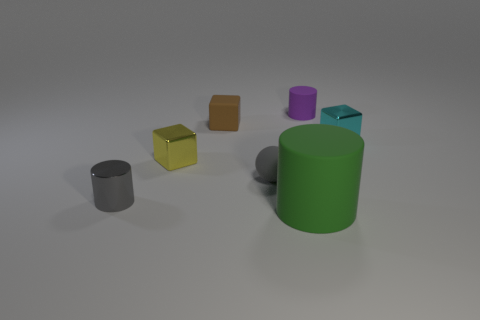Are there more small matte objects that are to the left of the big cylinder than tiny green balls?
Keep it short and to the point. Yes. Is there a block of the same color as the small sphere?
Provide a succinct answer. No. What color is the metal cylinder that is the same size as the sphere?
Your answer should be compact. Gray. There is a small cylinder that is to the right of the gray cylinder; are there any green rubber cylinders that are behind it?
Offer a terse response. No. What material is the tiny cylinder left of the tiny gray matte thing?
Your answer should be compact. Metal. Is the material of the small object that is right of the purple rubber thing the same as the small cylinder on the left side of the tiny purple cylinder?
Your answer should be compact. Yes. Are there an equal number of cubes that are on the left side of the tiny yellow thing and matte cylinders that are right of the large matte cylinder?
Keep it short and to the point. No. How many purple objects are made of the same material as the tiny cyan thing?
Offer a terse response. 0. What is the shape of the small metallic thing that is the same color as the small ball?
Provide a short and direct response. Cylinder. There is a matte cylinder behind the small cube that is right of the tiny purple cylinder; how big is it?
Provide a short and direct response. Small. 